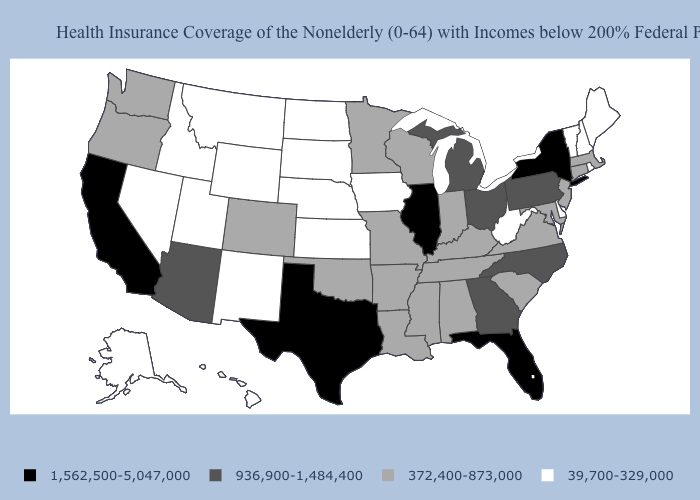What is the value of Nebraska?
Short answer required. 39,700-329,000. Does New Mexico have the same value as Michigan?
Keep it brief. No. Name the states that have a value in the range 372,400-873,000?
Give a very brief answer. Alabama, Arkansas, Colorado, Connecticut, Indiana, Kentucky, Louisiana, Maryland, Massachusetts, Minnesota, Mississippi, Missouri, New Jersey, Oklahoma, Oregon, South Carolina, Tennessee, Virginia, Washington, Wisconsin. Among the states that border Vermont , does New Hampshire have the highest value?
Concise answer only. No. Name the states that have a value in the range 1,562,500-5,047,000?
Keep it brief. California, Florida, Illinois, New York, Texas. What is the lowest value in states that border Connecticut?
Answer briefly. 39,700-329,000. Does Connecticut have a lower value than Arizona?
Give a very brief answer. Yes. Name the states that have a value in the range 1,562,500-5,047,000?
Keep it brief. California, Florida, Illinois, New York, Texas. Name the states that have a value in the range 1,562,500-5,047,000?
Answer briefly. California, Florida, Illinois, New York, Texas. What is the value of Mississippi?
Quick response, please. 372,400-873,000. Name the states that have a value in the range 1,562,500-5,047,000?
Give a very brief answer. California, Florida, Illinois, New York, Texas. What is the value of Virginia?
Short answer required. 372,400-873,000. Name the states that have a value in the range 1,562,500-5,047,000?
Be succinct. California, Florida, Illinois, New York, Texas. What is the value of Washington?
Concise answer only. 372,400-873,000. What is the lowest value in the USA?
Keep it brief. 39,700-329,000. 